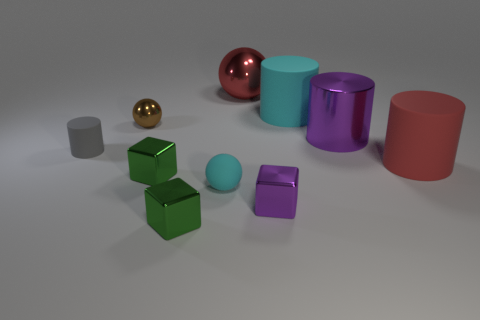Subtract all blue balls. How many green blocks are left? 2 Subtract 1 spheres. How many spheres are left? 2 Subtract all tiny green shiny blocks. How many blocks are left? 1 Subtract all brown cylinders. Subtract all blue balls. How many cylinders are left? 4 Subtract all cylinders. How many objects are left? 6 Subtract all small brown things. Subtract all large red metal objects. How many objects are left? 8 Add 6 gray objects. How many gray objects are left? 7 Add 9 gray cubes. How many gray cubes exist? 9 Subtract 1 red cylinders. How many objects are left? 9 